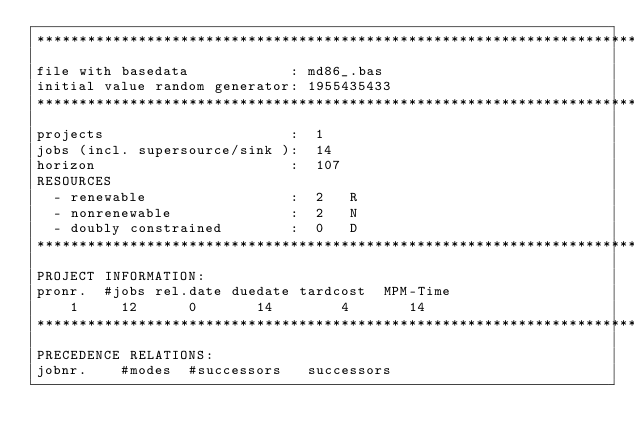<code> <loc_0><loc_0><loc_500><loc_500><_ObjectiveC_>************************************************************************
file with basedata            : md86_.bas
initial value random generator: 1955435433
************************************************************************
projects                      :  1
jobs (incl. supersource/sink ):  14
horizon                       :  107
RESOURCES
  - renewable                 :  2   R
  - nonrenewable              :  2   N
  - doubly constrained        :  0   D
************************************************************************
PROJECT INFORMATION:
pronr.  #jobs rel.date duedate tardcost  MPM-Time
    1     12      0       14        4       14
************************************************************************
PRECEDENCE RELATIONS:
jobnr.    #modes  #successors   successors</code> 